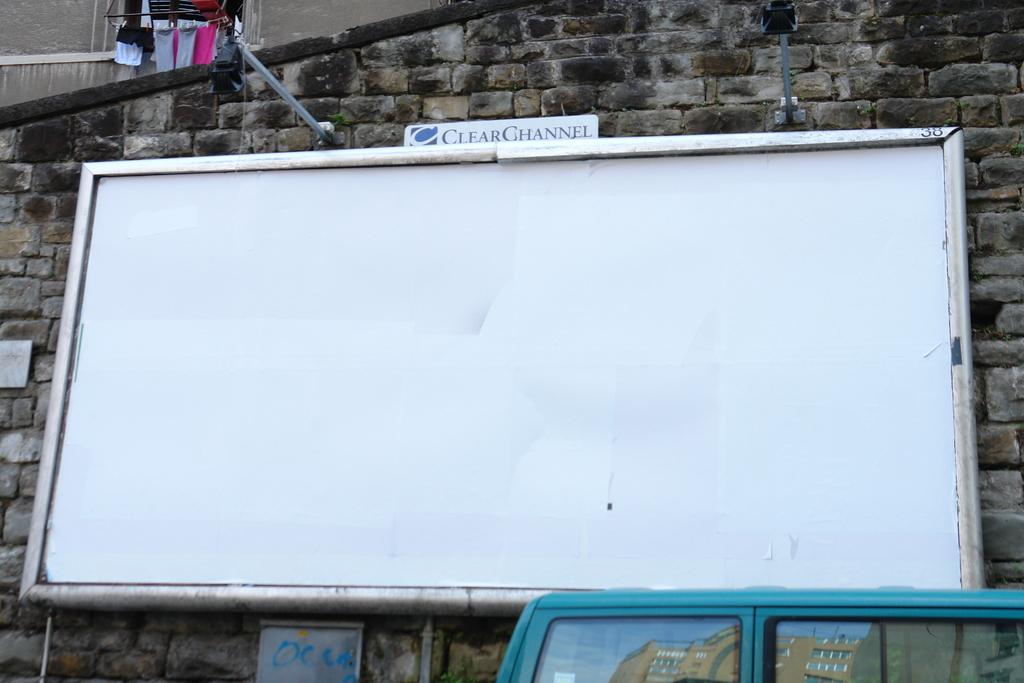<image>
Render a clear and concise summary of the photo. A large whiteboard is empty with the words CLEAR CHANNEL above it 